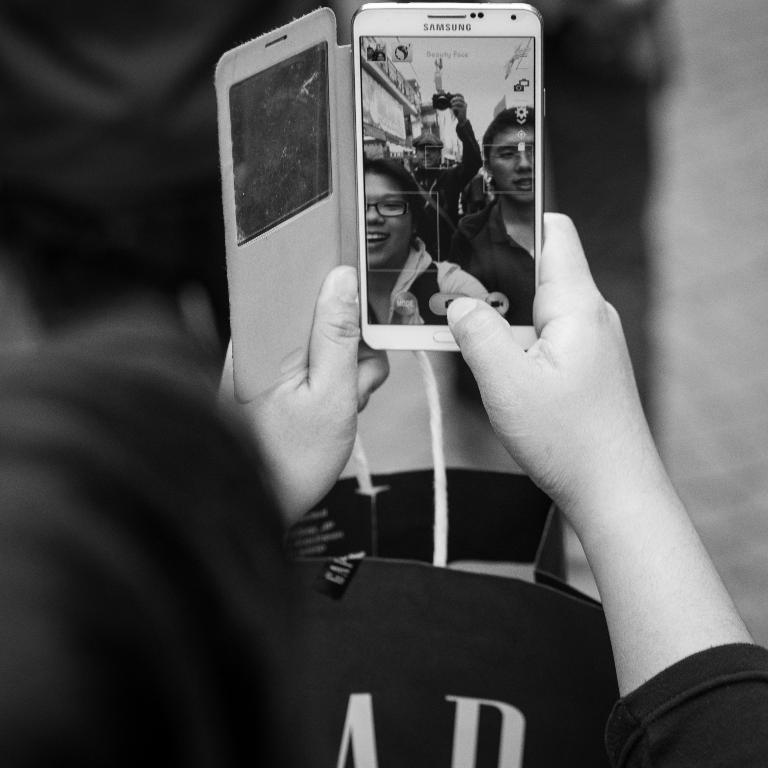<image>
Offer a succinct explanation of the picture presented. A woman face timing with other people on a samsung branded cell phone. 